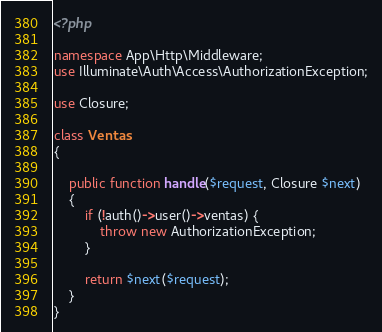<code> <loc_0><loc_0><loc_500><loc_500><_PHP_><?php

namespace App\Http\Middleware;
use Illuminate\Auth\Access\AuthorizationException;

use Closure;

class Ventas
{
   
    public function handle($request, Closure $next)
    {
        if (!auth()->user()->ventas) {
            throw new AuthorizationException;            
        }

        return $next($request);
    }
}
</code> 